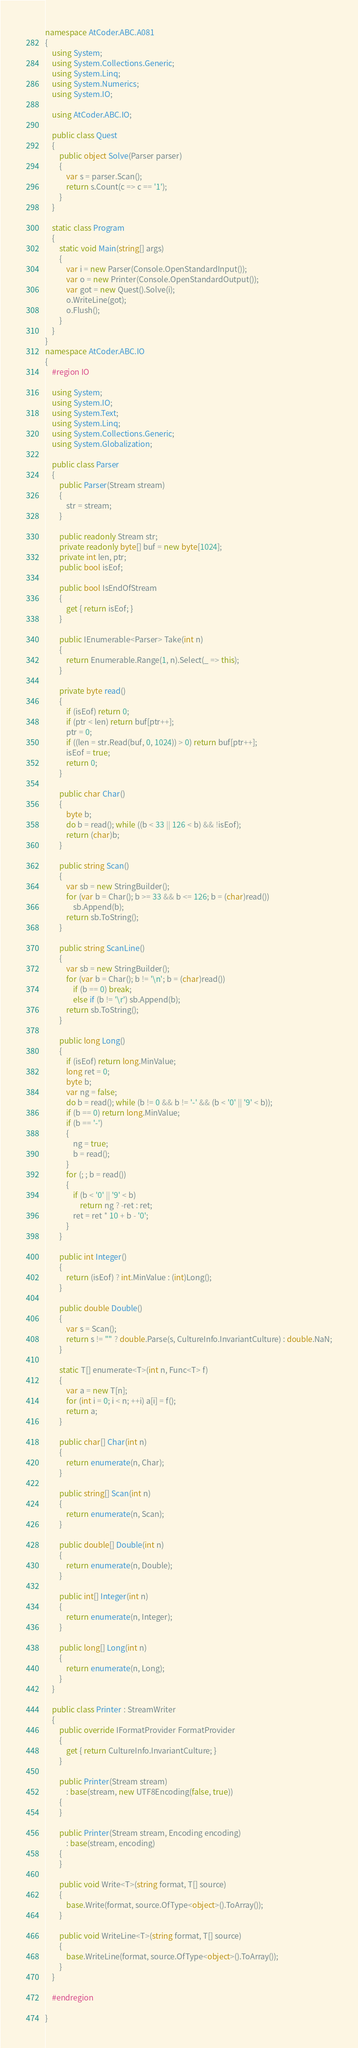Convert code to text. <code><loc_0><loc_0><loc_500><loc_500><_C#_>namespace AtCoder.ABC.A081
{
    using System;
    using System.Collections.Generic;
    using System.Linq;
    using System.Numerics;
    using System.IO;

    using AtCoder.ABC.IO;

    public class Quest
    {
        public object Solve(Parser parser)
        {
            var s = parser.Scan();
            return s.Count(c => c == '1');
        }
    }

    static class Program
    {
        static void Main(string[] args)
        {
            var i = new Parser(Console.OpenStandardInput());
            var o = new Printer(Console.OpenStandardOutput());
            var got = new Quest().Solve(i);
            o.WriteLine(got);
            o.Flush();
        }
    }
}
namespace AtCoder.ABC.IO
{
    #region IO

    using System;
    using System.IO;
    using System.Text;
    using System.Linq;
    using System.Collections.Generic;
    using System.Globalization;

    public class Parser
    {
        public Parser(Stream stream)
        {
            str = stream;
        }

        public readonly Stream str;
        private readonly byte[] buf = new byte[1024];
        private int len, ptr;
        public bool isEof;

        public bool IsEndOfStream
        {
            get { return isEof; }
        }

        public IEnumerable<Parser> Take(int n)
        {
            return Enumerable.Range(1, n).Select(_ => this);
        }

        private byte read()
        {
            if (isEof) return 0;
            if (ptr < len) return buf[ptr++];
            ptr = 0;
            if ((len = str.Read(buf, 0, 1024)) > 0) return buf[ptr++];
            isEof = true;
            return 0;
        }

        public char Char()
        {
            byte b;
            do b = read(); while ((b < 33 || 126 < b) && !isEof);
            return (char)b;
        }

        public string Scan()
        {
            var sb = new StringBuilder();
            for (var b = Char(); b >= 33 && b <= 126; b = (char)read())
                sb.Append(b);
            return sb.ToString();
        }

        public string ScanLine()
        {
            var sb = new StringBuilder();
            for (var b = Char(); b != '\n'; b = (char)read())
                if (b == 0) break;
                else if (b != '\r') sb.Append(b);
            return sb.ToString();
        }

        public long Long()
        {
            if (isEof) return long.MinValue;
            long ret = 0;
            byte b;
            var ng = false;
            do b = read(); while (b != 0 && b != '-' && (b < '0' || '9' < b));
            if (b == 0) return long.MinValue;
            if (b == '-')
            {
                ng = true;
                b = read();
            }
            for (; ; b = read())
            {
                if (b < '0' || '9' < b)
                    return ng ? -ret : ret;
                ret = ret * 10 + b - '0';
            }
        }

        public int Integer()
        {
            return (isEof) ? int.MinValue : (int)Long();
        }

        public double Double()
        {
            var s = Scan();
            return s != "" ? double.Parse(s, CultureInfo.InvariantCulture) : double.NaN;
        }

        static T[] enumerate<T>(int n, Func<T> f)
        {
            var a = new T[n];
            for (int i = 0; i < n; ++i) a[i] = f();
            return a;
        }

        public char[] Char(int n)
        {
            return enumerate(n, Char);
        }

        public string[] Scan(int n)
        {
            return enumerate(n, Scan);
        }

        public double[] Double(int n)
        {
            return enumerate(n, Double);
        }

        public int[] Integer(int n)
        {
            return enumerate(n, Integer);
        }

        public long[] Long(int n)
        {
            return enumerate(n, Long);
        }
    }

    public class Printer : StreamWriter
    {
        public override IFormatProvider FormatProvider
        {
            get { return CultureInfo.InvariantCulture; }
        }

        public Printer(Stream stream)
            : base(stream, new UTF8Encoding(false, true))
        {
        }

        public Printer(Stream stream, Encoding encoding)
            : base(stream, encoding)
        {
        }

        public void Write<T>(string format, T[] source)
        {
            base.Write(format, source.OfType<object>().ToArray());
        }

        public void WriteLine<T>(string format, T[] source)
        {
            base.WriteLine(format, source.OfType<object>().ToArray());
        }
    }

    #endregion

}</code> 